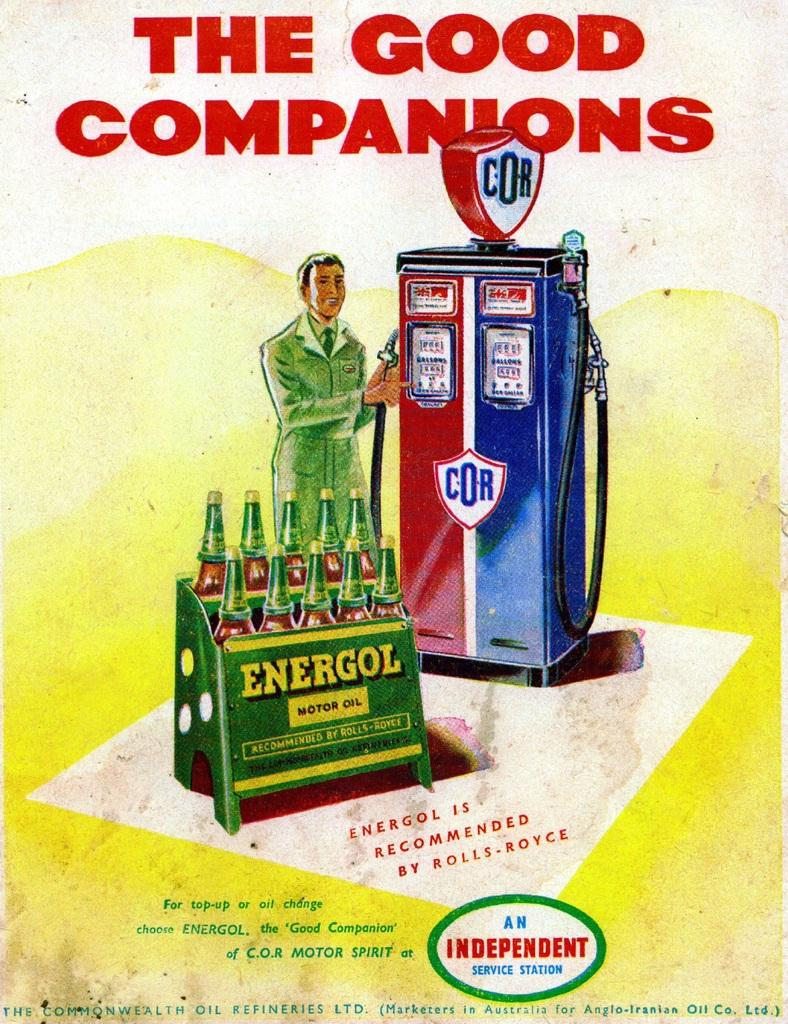<image>
Present a compact description of the photo's key features. A sign saying "The Good Companions" is showing a man 